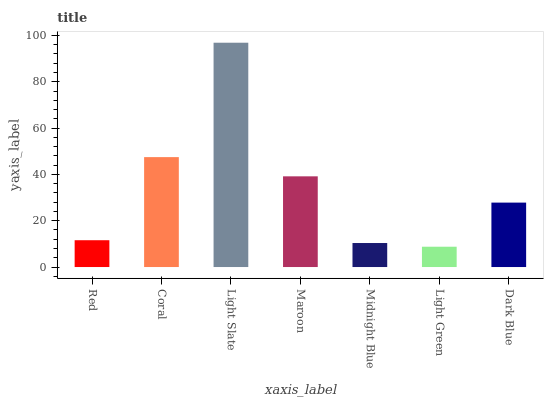Is Light Green the minimum?
Answer yes or no. Yes. Is Light Slate the maximum?
Answer yes or no. Yes. Is Coral the minimum?
Answer yes or no. No. Is Coral the maximum?
Answer yes or no. No. Is Coral greater than Red?
Answer yes or no. Yes. Is Red less than Coral?
Answer yes or no. Yes. Is Red greater than Coral?
Answer yes or no. No. Is Coral less than Red?
Answer yes or no. No. Is Dark Blue the high median?
Answer yes or no. Yes. Is Dark Blue the low median?
Answer yes or no. Yes. Is Coral the high median?
Answer yes or no. No. Is Maroon the low median?
Answer yes or no. No. 